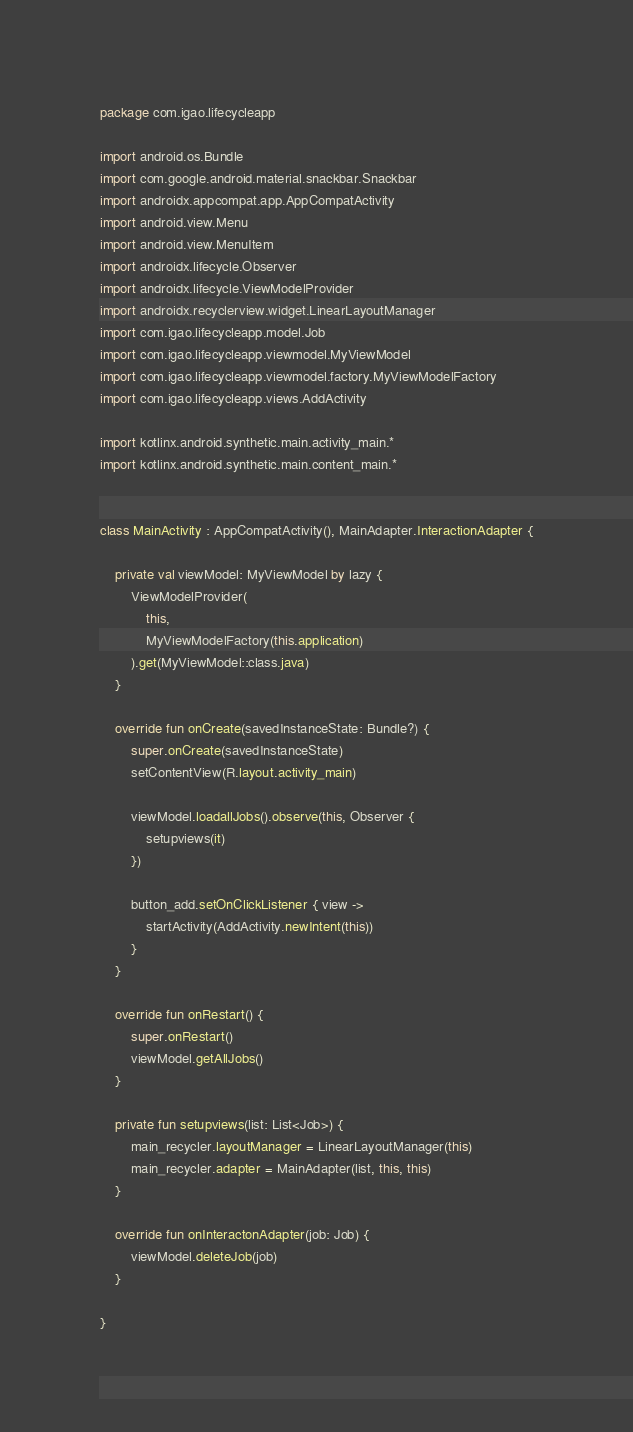<code> <loc_0><loc_0><loc_500><loc_500><_Kotlin_>package com.igao.lifecycleapp

import android.os.Bundle
import com.google.android.material.snackbar.Snackbar
import androidx.appcompat.app.AppCompatActivity
import android.view.Menu
import android.view.MenuItem
import androidx.lifecycle.Observer
import androidx.lifecycle.ViewModelProvider
import androidx.recyclerview.widget.LinearLayoutManager
import com.igao.lifecycleapp.model.Job
import com.igao.lifecycleapp.viewmodel.MyViewModel
import com.igao.lifecycleapp.viewmodel.factory.MyViewModelFactory
import com.igao.lifecycleapp.views.AddActivity

import kotlinx.android.synthetic.main.activity_main.*
import kotlinx.android.synthetic.main.content_main.*


class MainActivity : AppCompatActivity(), MainAdapter.InteractionAdapter {

    private val viewModel: MyViewModel by lazy {
        ViewModelProvider(
            this,
            MyViewModelFactory(this.application)
        ).get(MyViewModel::class.java)
    }

    override fun onCreate(savedInstanceState: Bundle?) {
        super.onCreate(savedInstanceState)
        setContentView(R.layout.activity_main)

        viewModel.loadallJobs().observe(this, Observer {
            setupviews(it)
        })

        button_add.setOnClickListener { view ->
            startActivity(AddActivity.newIntent(this))
        }
    }

    override fun onRestart() {
        super.onRestart()
        viewModel.getAllJobs()
    }

    private fun setupviews(list: List<Job>) {
        main_recycler.layoutManager = LinearLayoutManager(this)
        main_recycler.adapter = MainAdapter(list, this, this)
    }

    override fun onInteractonAdapter(job: Job) {
        viewModel.deleteJob(job)
    }

}
</code> 